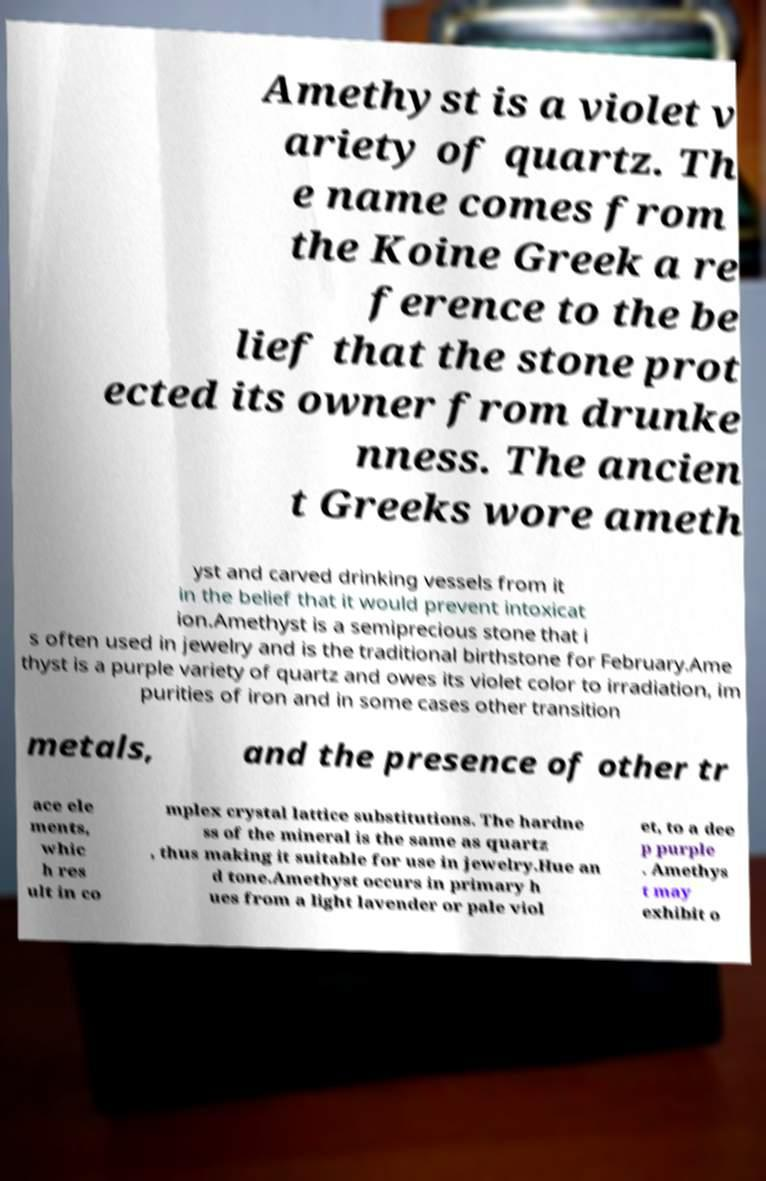Please identify and transcribe the text found in this image. Amethyst is a violet v ariety of quartz. Th e name comes from the Koine Greek a re ference to the be lief that the stone prot ected its owner from drunke nness. The ancien t Greeks wore ameth yst and carved drinking vessels from it in the belief that it would prevent intoxicat ion.Amethyst is a semiprecious stone that i s often used in jewelry and is the traditional birthstone for February.Ame thyst is a purple variety of quartz and owes its violet color to irradiation, im purities of iron and in some cases other transition metals, and the presence of other tr ace ele ments, whic h res ult in co mplex crystal lattice substitutions. The hardne ss of the mineral is the same as quartz , thus making it suitable for use in jewelry.Hue an d tone.Amethyst occurs in primary h ues from a light lavender or pale viol et, to a dee p purple . Amethys t may exhibit o 